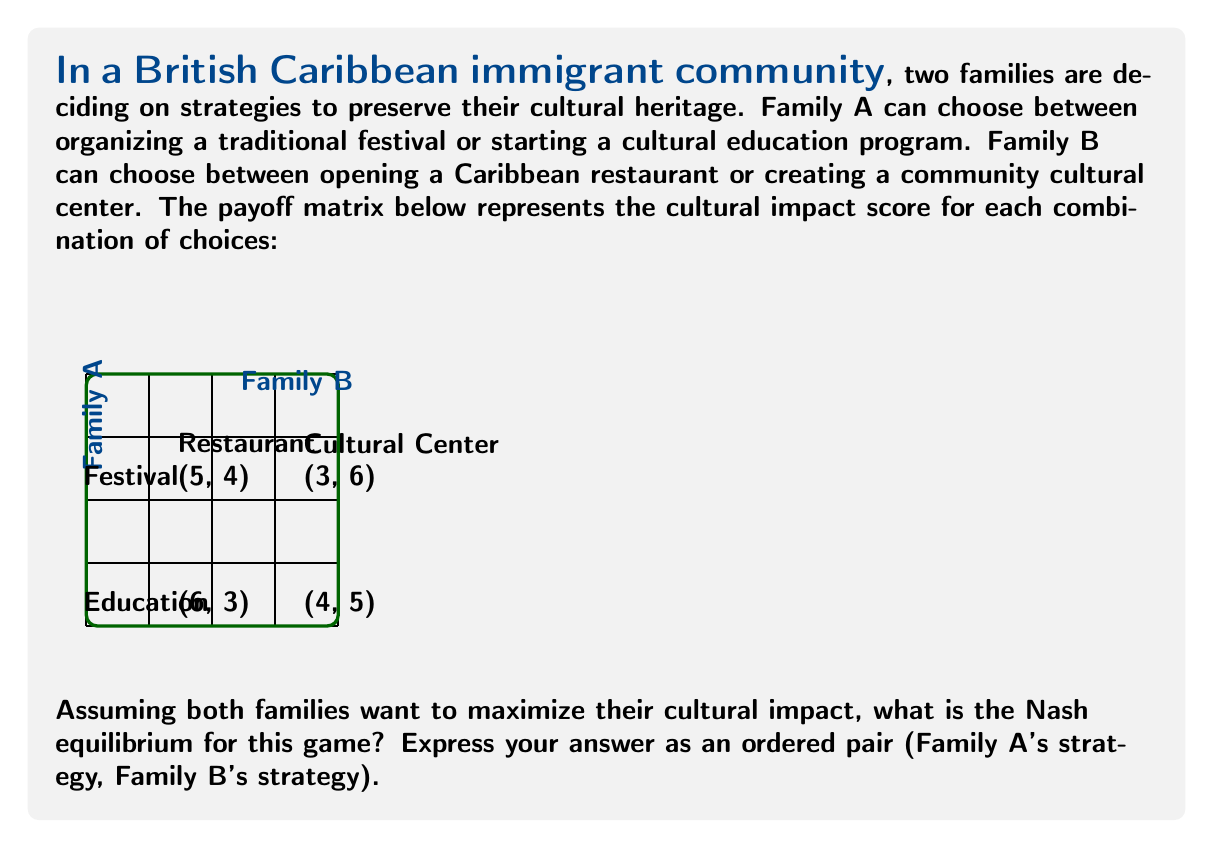Solve this math problem. To find the Nash equilibrium, we need to determine the best response for each family given the other family's strategy:

1. Family A's perspective:
   - If B chooses Restaurant:
     Festival payoff: 5
     Education payoff: 6
     Best response: Education
   - If B chooses Cultural Center:
     Festival payoff: 3
     Education payoff: 4
     Best response: Education

2. Family B's perspective:
   - If A chooses Festival:
     Restaurant payoff: 4
     Cultural Center payoff: 6
     Best response: Cultural Center
   - If A chooses Education:
     Restaurant payoff: 3
     Cultural Center payoff: 5
     Best response: Cultural Center

3. Nash equilibrium:
   A Nash equilibrium occurs when both families are playing their best response to the other's strategy. From our analysis:
   - Family A's best response is always Education
   - Family B's best response is always Cultural Center

Therefore, the Nash equilibrium is (Education, Cultural Center) with payoffs (4, 5).

This equilibrium represents a stable outcome where neither family can unilaterally improve their cultural impact by changing their strategy. It suggests that in this British Caribbean immigrant community, a combination of cultural education programs and a community cultural center would be the most effective strategy for cultural preservation.
Answer: (Education, Cultural Center) 